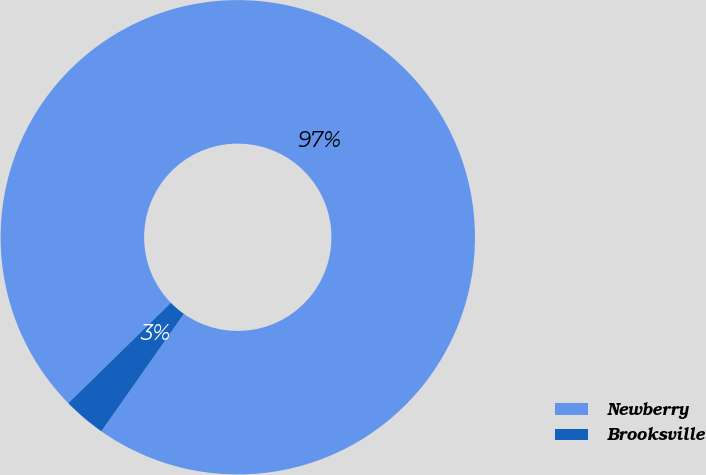Convert chart to OTSL. <chart><loc_0><loc_0><loc_500><loc_500><pie_chart><fcel>Newberry<fcel>Brooksville<nl><fcel>97.08%<fcel>2.92%<nl></chart> 